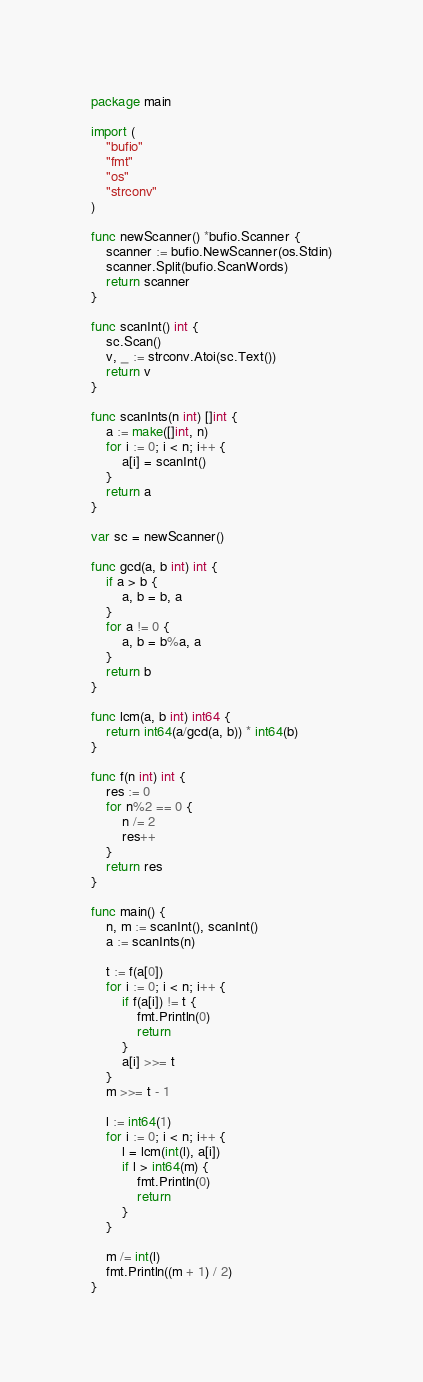Convert code to text. <code><loc_0><loc_0><loc_500><loc_500><_Go_>package main

import (
	"bufio"
	"fmt"
	"os"
	"strconv"
)

func newScanner() *bufio.Scanner {
	scanner := bufio.NewScanner(os.Stdin)
	scanner.Split(bufio.ScanWords)
	return scanner
}

func scanInt() int {
	sc.Scan()
	v, _ := strconv.Atoi(sc.Text())
	return v
}

func scanInts(n int) []int {
	a := make([]int, n)
	for i := 0; i < n; i++ {
		a[i] = scanInt()
	}
	return a
}

var sc = newScanner()

func gcd(a, b int) int {
	if a > b {
		a, b = b, a
	}
	for a != 0 {
		a, b = b%a, a
	}
	return b
}

func lcm(a, b int) int64 {
	return int64(a/gcd(a, b)) * int64(b)
}

func f(n int) int {
	res := 0
	for n%2 == 0 {
		n /= 2
		res++
	}
	return res
}

func main() {
	n, m := scanInt(), scanInt()
	a := scanInts(n)

	t := f(a[0])
	for i := 0; i < n; i++ {
		if f(a[i]) != t {
			fmt.Println(0)
			return
		}
		a[i] >>= t
	}
	m >>= t - 1

	l := int64(1)
	for i := 0; i < n; i++ {
		l = lcm(int(l), a[i])
		if l > int64(m) {
			fmt.Println(0)
			return
		}
	}

	m /= int(l)
	fmt.Println((m + 1) / 2)
}
</code> 